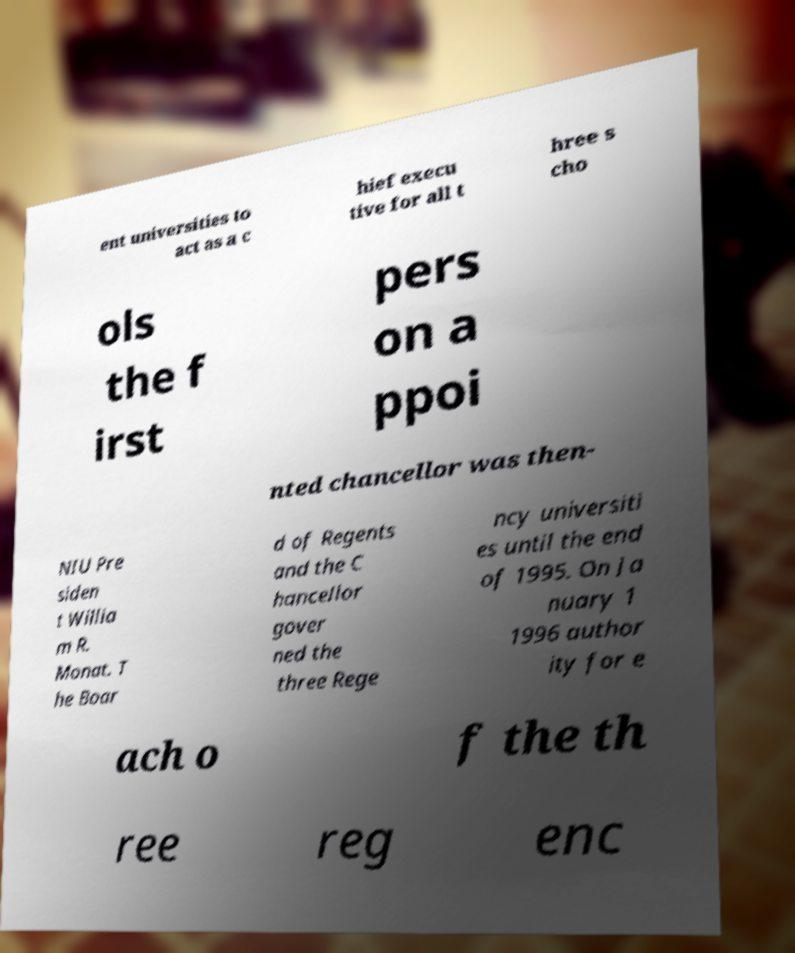What messages or text are displayed in this image? I need them in a readable, typed format. ent universities to act as a c hief execu tive for all t hree s cho ols the f irst pers on a ppoi nted chancellor was then- NIU Pre siden t Willia m R. Monat. T he Boar d of Regents and the C hancellor gover ned the three Rege ncy universiti es until the end of 1995. On Ja nuary 1 1996 author ity for e ach o f the th ree reg enc 